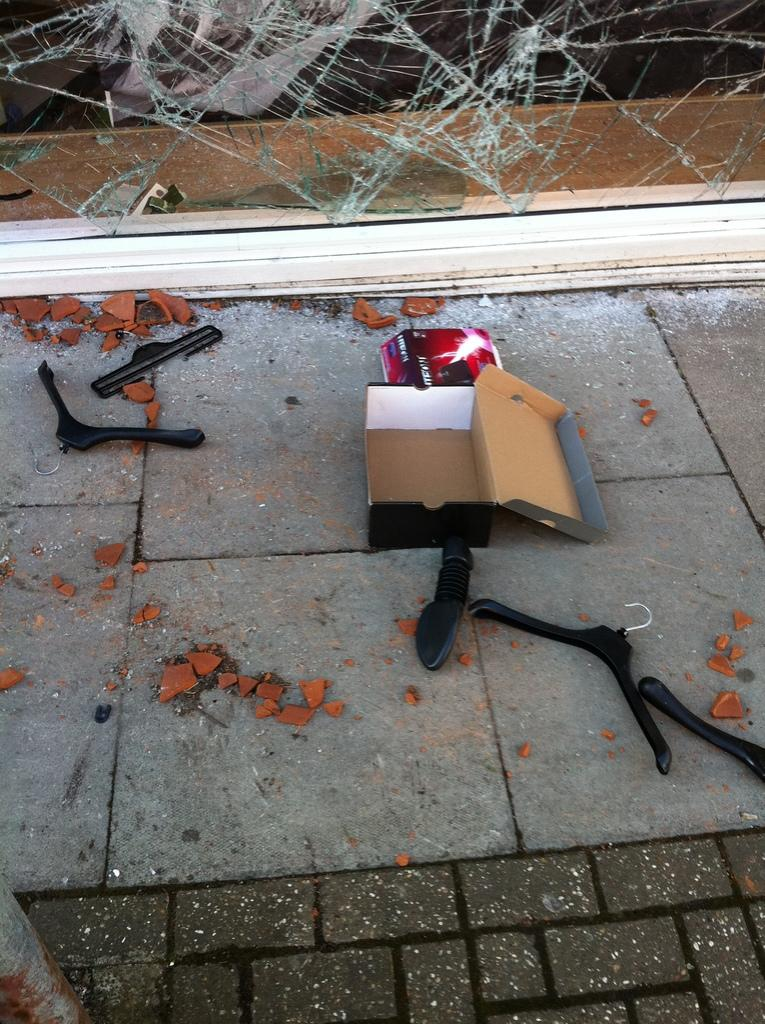What objects are present in the image that are typically used for storage? There are boxes in the image. What objects are present in the image that are typically used for hanging clothes? There are hangers in the image. What type of debris can be seen on the road in the image? There are broken pot pieces on the road in the image. What type of broken object can be seen in the background of the image? There is a broken glass in the background of the image. Where is the calendar located in the image? There is no calendar present in the image. What type of fuel is being used by the vehicles in the image? There are no vehicles present in the image, so it is not possible to determine what type of fuel they might be using. 